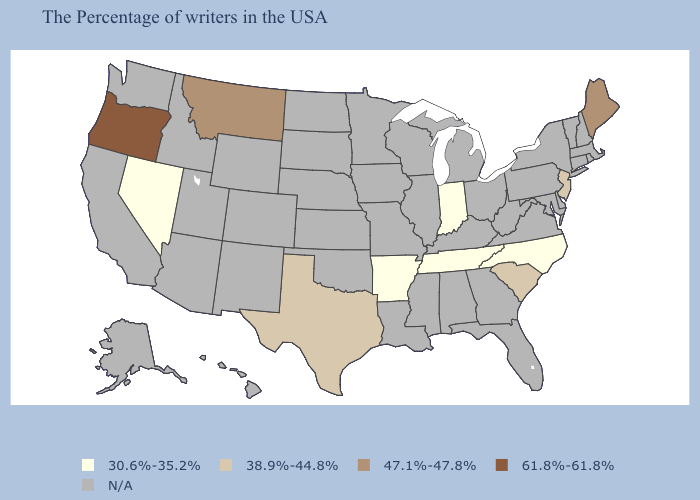Does Oregon have the highest value in the USA?
Quick response, please. Yes. What is the lowest value in the West?
Short answer required. 30.6%-35.2%. What is the highest value in the USA?
Write a very short answer. 61.8%-61.8%. Is the legend a continuous bar?
Quick response, please. No. Does the map have missing data?
Be succinct. Yes. What is the value of Kentucky?
Write a very short answer. N/A. Is the legend a continuous bar?
Keep it brief. No. What is the highest value in the USA?
Keep it brief. 61.8%-61.8%. Name the states that have a value in the range N/A?
Keep it brief. Massachusetts, Rhode Island, New Hampshire, Vermont, Connecticut, New York, Delaware, Maryland, Pennsylvania, Virginia, West Virginia, Ohio, Florida, Georgia, Michigan, Kentucky, Alabama, Wisconsin, Illinois, Mississippi, Louisiana, Missouri, Minnesota, Iowa, Kansas, Nebraska, Oklahoma, South Dakota, North Dakota, Wyoming, Colorado, New Mexico, Utah, Arizona, Idaho, California, Washington, Alaska, Hawaii. 